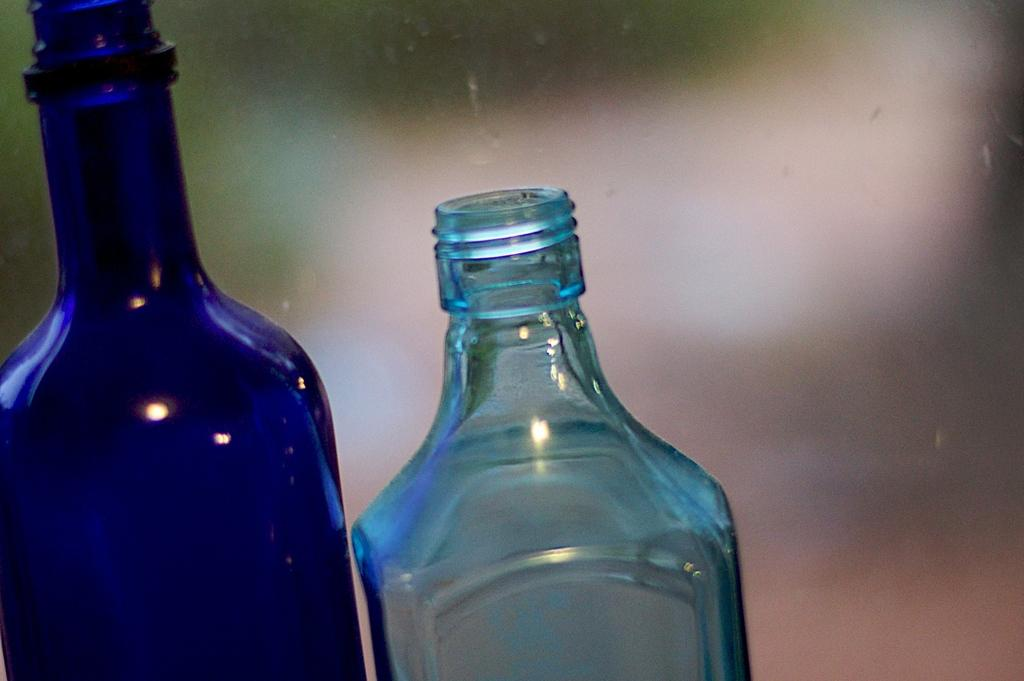How many water bottles are visible in the image? There are two water bottles in the image. What is the state of the water bottles in terms of their caps? The water bottles do not have caps. What type of tail can be seen on the water bottles in the image? There are no tails present on the water bottles in the image. What type of paste is being used to seal the water bottles in the image? There is no paste visible on the water bottles in the image. 